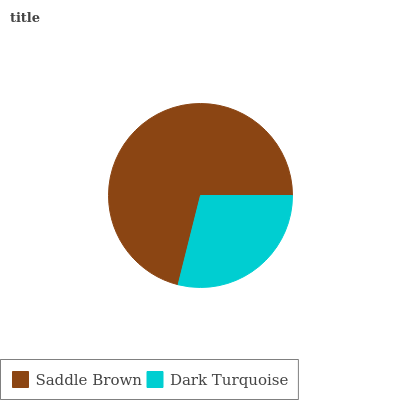Is Dark Turquoise the minimum?
Answer yes or no. Yes. Is Saddle Brown the maximum?
Answer yes or no. Yes. Is Dark Turquoise the maximum?
Answer yes or no. No. Is Saddle Brown greater than Dark Turquoise?
Answer yes or no. Yes. Is Dark Turquoise less than Saddle Brown?
Answer yes or no. Yes. Is Dark Turquoise greater than Saddle Brown?
Answer yes or no. No. Is Saddle Brown less than Dark Turquoise?
Answer yes or no. No. Is Saddle Brown the high median?
Answer yes or no. Yes. Is Dark Turquoise the low median?
Answer yes or no. Yes. Is Dark Turquoise the high median?
Answer yes or no. No. Is Saddle Brown the low median?
Answer yes or no. No. 